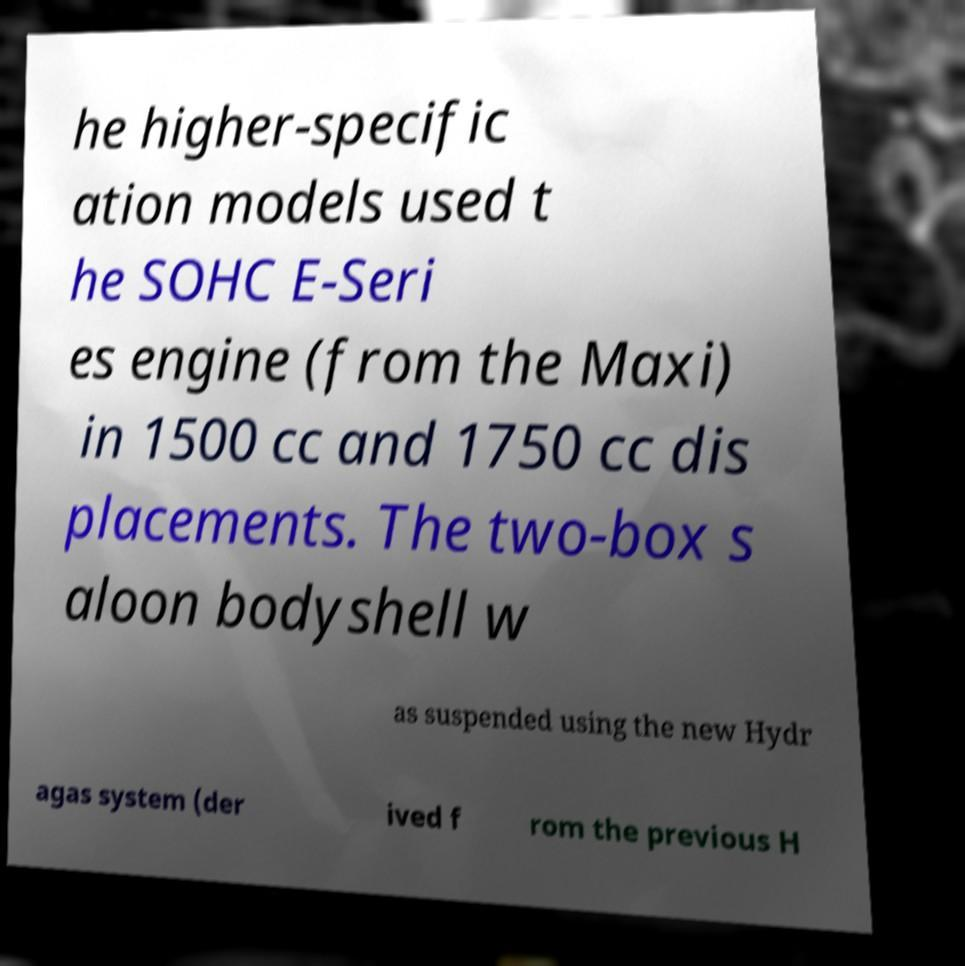Please read and relay the text visible in this image. What does it say? he higher-specific ation models used t he SOHC E-Seri es engine (from the Maxi) in 1500 cc and 1750 cc dis placements. The two-box s aloon bodyshell w as suspended using the new Hydr agas system (der ived f rom the previous H 